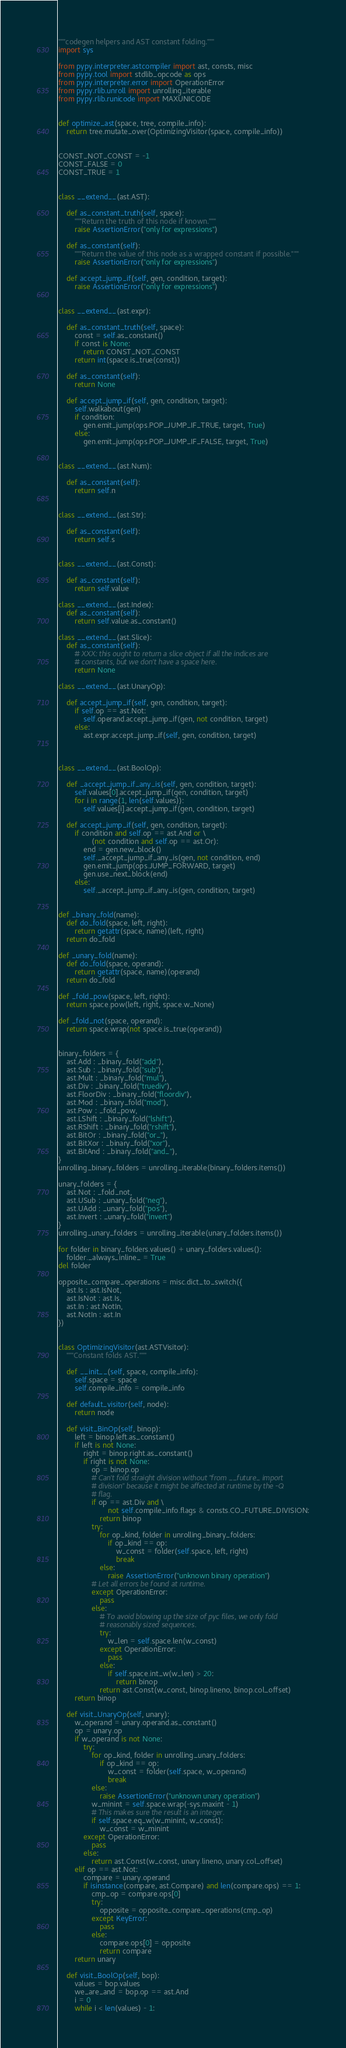Convert code to text. <code><loc_0><loc_0><loc_500><loc_500><_Python_>"""codegen helpers and AST constant folding."""
import sys

from pypy.interpreter.astcompiler import ast, consts, misc
from pypy.tool import stdlib_opcode as ops
from pypy.interpreter.error import OperationError
from pypy.rlib.unroll import unrolling_iterable
from pypy.rlib.runicode import MAXUNICODE


def optimize_ast(space, tree, compile_info):
    return tree.mutate_over(OptimizingVisitor(space, compile_info))


CONST_NOT_CONST = -1
CONST_FALSE = 0
CONST_TRUE = 1


class __extend__(ast.AST):

    def as_constant_truth(self, space):
        """Return the truth of this node if known."""
        raise AssertionError("only for expressions")

    def as_constant(self):
        """Return the value of this node as a wrapped constant if possible."""
        raise AssertionError("only for expressions")

    def accept_jump_if(self, gen, condition, target):
        raise AssertionError("only for expressions")


class __extend__(ast.expr):

    def as_constant_truth(self, space):
        const = self.as_constant()
        if const is None:
            return CONST_NOT_CONST
        return int(space.is_true(const))

    def as_constant(self):
        return None

    def accept_jump_if(self, gen, condition, target):
        self.walkabout(gen)
        if condition:
            gen.emit_jump(ops.POP_JUMP_IF_TRUE, target, True)
        else:
            gen.emit_jump(ops.POP_JUMP_IF_FALSE, target, True)


class __extend__(ast.Num):

    def as_constant(self):
        return self.n


class __extend__(ast.Str):

    def as_constant(self):
        return self.s


class __extend__(ast.Const):

    def as_constant(self):
        return self.value

class __extend__(ast.Index):
    def as_constant(self):
        return self.value.as_constant()

class __extend__(ast.Slice):
    def as_constant(self):
        # XXX: this ought to return a slice object if all the indices are
        # constants, but we don't have a space here.
        return None

class __extend__(ast.UnaryOp):

    def accept_jump_if(self, gen, condition, target):
        if self.op == ast.Not:
            self.operand.accept_jump_if(gen, not condition, target)
        else:
            ast.expr.accept_jump_if(self, gen, condition, target)



class __extend__(ast.BoolOp):

    def _accept_jump_if_any_is(self, gen, condition, target):
        self.values[0].accept_jump_if(gen, condition, target)
        for i in range(1, len(self.values)):
            self.values[i].accept_jump_if(gen, condition, target)

    def accept_jump_if(self, gen, condition, target):
        if condition and self.op == ast.And or \
                (not condition and self.op == ast.Or):
            end = gen.new_block()
            self._accept_jump_if_any_is(gen, not condition, end)
            gen.emit_jump(ops.JUMP_FORWARD, target)
            gen.use_next_block(end)
        else:
            self._accept_jump_if_any_is(gen, condition, target)


def _binary_fold(name):
    def do_fold(space, left, right):
        return getattr(space, name)(left, right)
    return do_fold

def _unary_fold(name):
    def do_fold(space, operand):
        return getattr(space, name)(operand)
    return do_fold

def _fold_pow(space, left, right):
    return space.pow(left, right, space.w_None)

def _fold_not(space, operand):
    return space.wrap(not space.is_true(operand))


binary_folders = {
    ast.Add : _binary_fold("add"),
    ast.Sub : _binary_fold("sub"),
    ast.Mult : _binary_fold("mul"),
    ast.Div : _binary_fold("truediv"),
    ast.FloorDiv : _binary_fold("floordiv"),
    ast.Mod : _binary_fold("mod"),
    ast.Pow : _fold_pow,
    ast.LShift : _binary_fold("lshift"),
    ast.RShift : _binary_fold("rshift"),
    ast.BitOr : _binary_fold("or_"),
    ast.BitXor : _binary_fold("xor"),
    ast.BitAnd : _binary_fold("and_"),
}
unrolling_binary_folders = unrolling_iterable(binary_folders.items())

unary_folders = {
    ast.Not : _fold_not,
    ast.USub : _unary_fold("neg"),
    ast.UAdd : _unary_fold("pos"),
    ast.Invert : _unary_fold("invert")
}
unrolling_unary_folders = unrolling_iterable(unary_folders.items())

for folder in binary_folders.values() + unary_folders.values():
    folder._always_inline_ = True
del folder

opposite_compare_operations = misc.dict_to_switch({
    ast.Is : ast.IsNot,
    ast.IsNot : ast.Is,
    ast.In : ast.NotIn,
    ast.NotIn : ast.In
})


class OptimizingVisitor(ast.ASTVisitor):
    """Constant folds AST."""

    def __init__(self, space, compile_info):
        self.space = space
        self.compile_info = compile_info

    def default_visitor(self, node):
        return node

    def visit_BinOp(self, binop):
        left = binop.left.as_constant()
        if left is not None:
            right = binop.right.as_constant()
            if right is not None:
                op = binop.op
                # Can't fold straight division without "from __future_ import
                # division" because it might be affected at runtime by the -Q
                # flag.
                if op == ast.Div and \
                        not self.compile_info.flags & consts.CO_FUTURE_DIVISION:
                    return binop
                try:
                    for op_kind, folder in unrolling_binary_folders:
                        if op_kind == op:
                            w_const = folder(self.space, left, right)
                            break
                    else:
                        raise AssertionError("unknown binary operation")
                # Let all errors be found at runtime.
                except OperationError:
                    pass
                else:
                    # To avoid blowing up the size of pyc files, we only fold
                    # reasonably sized sequences.
                    try:
                        w_len = self.space.len(w_const)
                    except OperationError:
                        pass
                    else:
                        if self.space.int_w(w_len) > 20:
                            return binop
                    return ast.Const(w_const, binop.lineno, binop.col_offset)
        return binop

    def visit_UnaryOp(self, unary):
        w_operand = unary.operand.as_constant()
        op = unary.op
        if w_operand is not None:
            try:
                for op_kind, folder in unrolling_unary_folders:
                    if op_kind == op:
                        w_const = folder(self.space, w_operand)
                        break
                else:
                    raise AssertionError("unknown unary operation")
                w_minint = self.space.wrap(-sys.maxint - 1)
                # This makes sure the result is an integer.
                if self.space.eq_w(w_minint, w_const):
                    w_const = w_minint
            except OperationError:
                pass
            else:
                return ast.Const(w_const, unary.lineno, unary.col_offset)
        elif op == ast.Not:
            compare = unary.operand
            if isinstance(compare, ast.Compare) and len(compare.ops) == 1:
                cmp_op = compare.ops[0]
                try:
                    opposite = opposite_compare_operations(cmp_op)
                except KeyError:
                    pass
                else:
                    compare.ops[0] = opposite
                    return compare
        return unary

    def visit_BoolOp(self, bop):
        values = bop.values
        we_are_and = bop.op == ast.And
        i = 0
        while i < len(values) - 1:</code> 